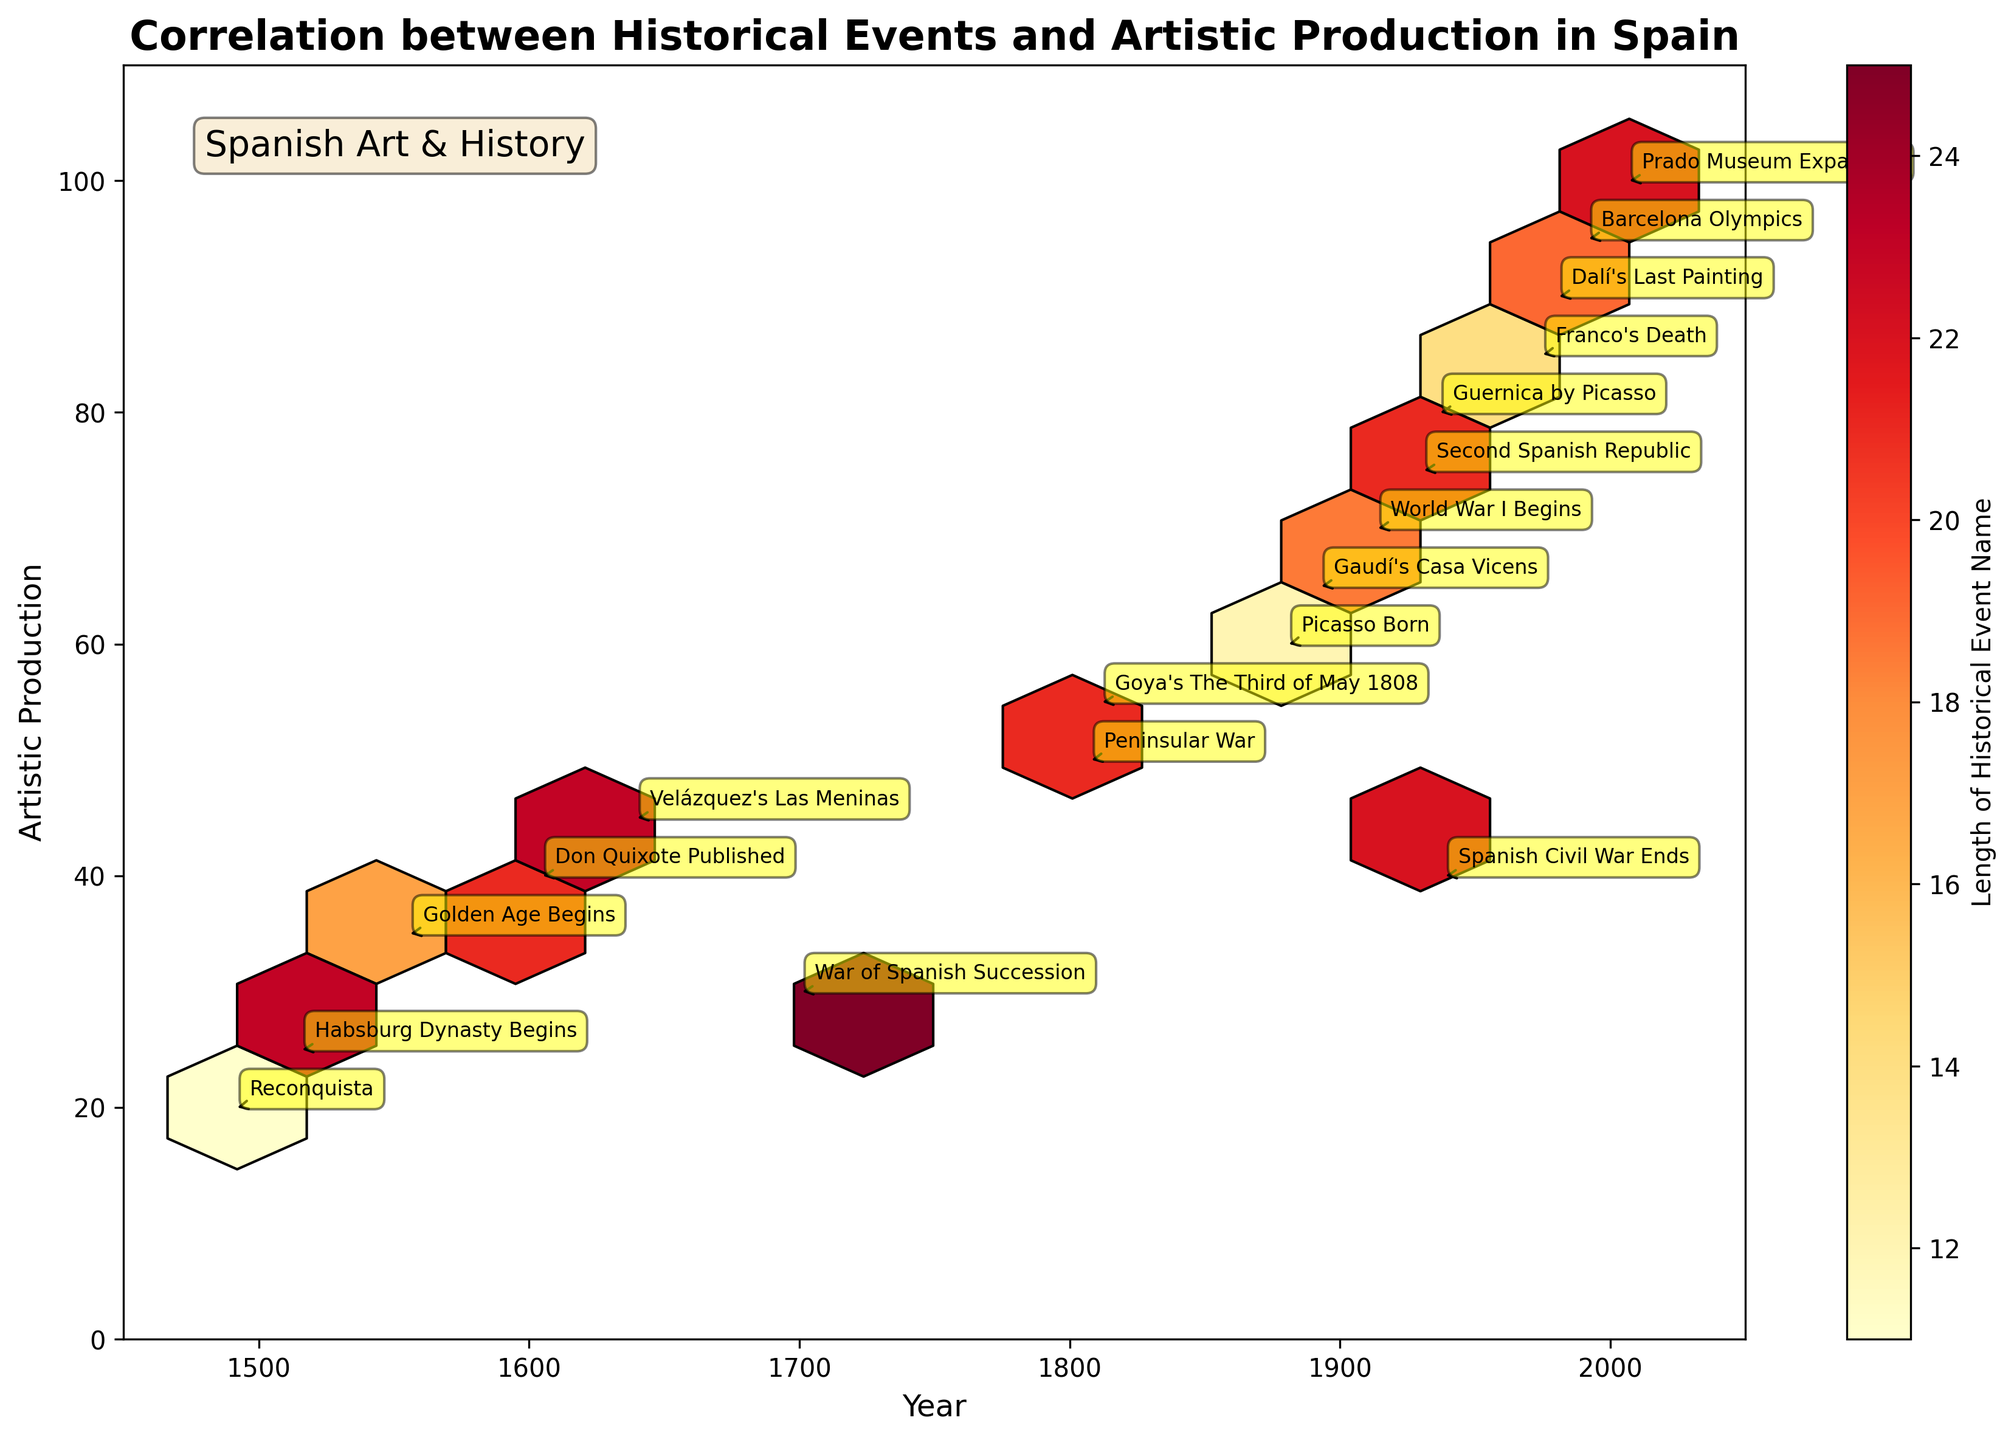What is the title of the plot? The title of the plot is displayed at the top and reads "Correlation between Historical Events and Artistic Production in Spain."
Answer: Correlation between Historical Events and Artistic Production in Spain What is the range of years considered in the plot? Observing the x-axis of the plot, the range of years spans from 1450 to 2050.
Answer: 1450 to 2050 Which historical event corresponds to the peak in artistic production? By looking at the y-axis values for artistic production, the highest value is 100, which corresponds to the "Prado Museum Expansion" in 2007.
Answer: Prado Museum Expansion What was the artistic production value during the year Don Quixote was published? From the annotations on the plot, the year Don Quixote was published (1605) has an artistic production value of 40.
Answer: 40 Between which years did artistic production increase the most? Comparing the steepness of increases on the y-axis, the most significant increase occurs from the year 1939 (Spanish Civil War Ends) at 40 to the year 1975 (Franco's Death) at 85.
Answer: 1939 to 1975 How many data points are there on the plot? Counting the total number of annotations for historical events, there are 18 data points on the plot.
Answer: 18 Which historical event has the longest name according to the color intensity on the plot? The color bar indicates that longer names have a higher color intensity (darker color). The event with the longest name, judging from the darkest color, is "Peninsular War."
Answer: Peninsular War What is the artistic production value at the start of the Habsburg Dynasty? From the plot, the start of the Habsburg Dynasty (1516) corresponds to an artistic production value of 25.
Answer: 25 How does the artistic production in 1640 (Velázquez's Las Meninas) compare to that in 1701 (War of Spanish Succession)? Artistic production for 1640 (Velázquez's Las Meninas) is 45, while for 1701 (War of Spanish Succession) is 30. Therefore, production in 1640 is higher.
Answer: 1640 is higher How does the length of historical event names trend over time? Observing the intensity of hexbin colors over the years on the x-axis, there is no clear trend of increasing or decreasing name length over time.
Answer: No clear trend 